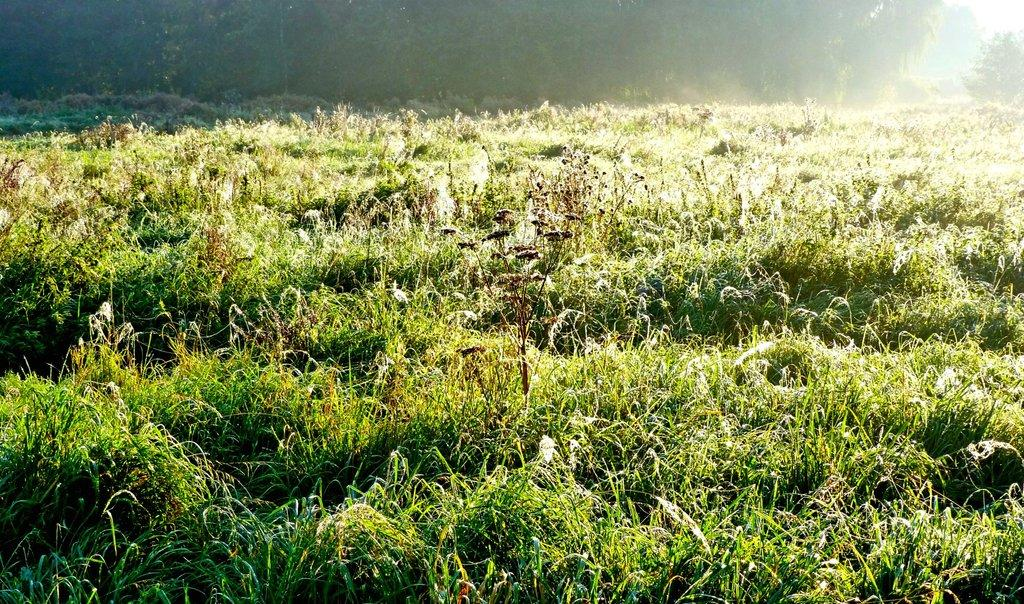What type of landscape is depicted in the image? The image contains farmland. What can be seen in the background of the image? There are many trees in the background of the image. What type of vegetation is visible at the bottom of the image? There are plants visible at the bottom of the image. What part of the sky is visible in the image? The sky is visible in the top right corner of the image. What type of loaf is being baked in the farmland depicted in the image? There is no loaf or baking activity present in the image; it features farmland with trees and plants. 